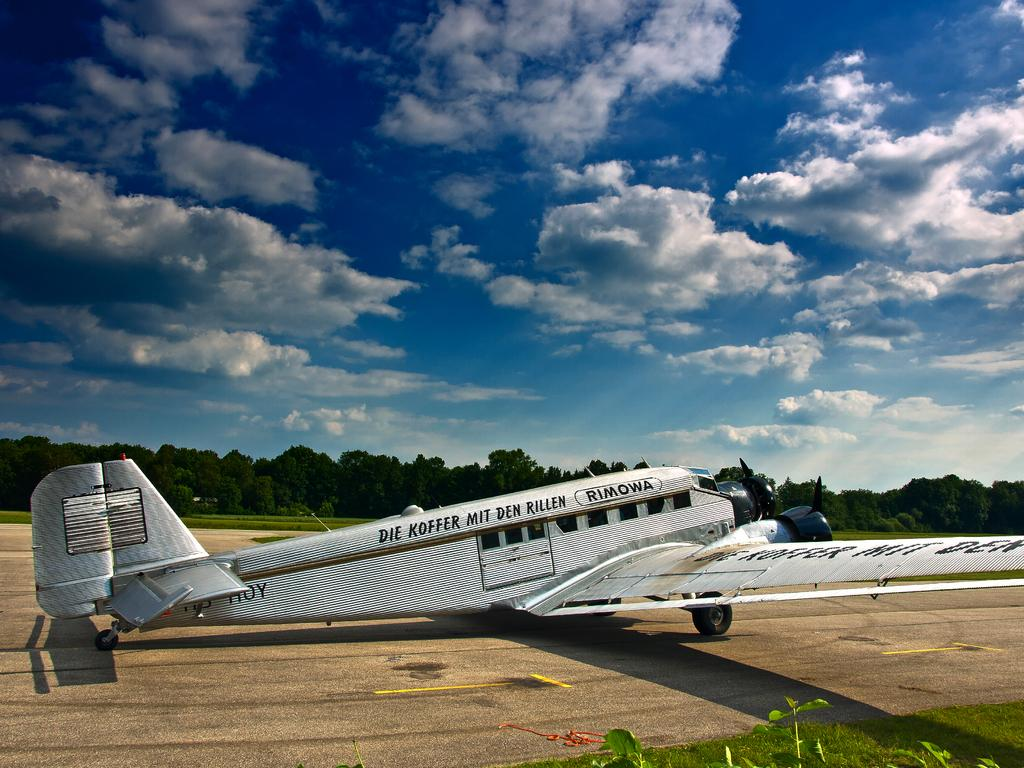<image>
Relay a brief, clear account of the picture shown. An airplane with the words Die Koffer Mit Den Rillen 